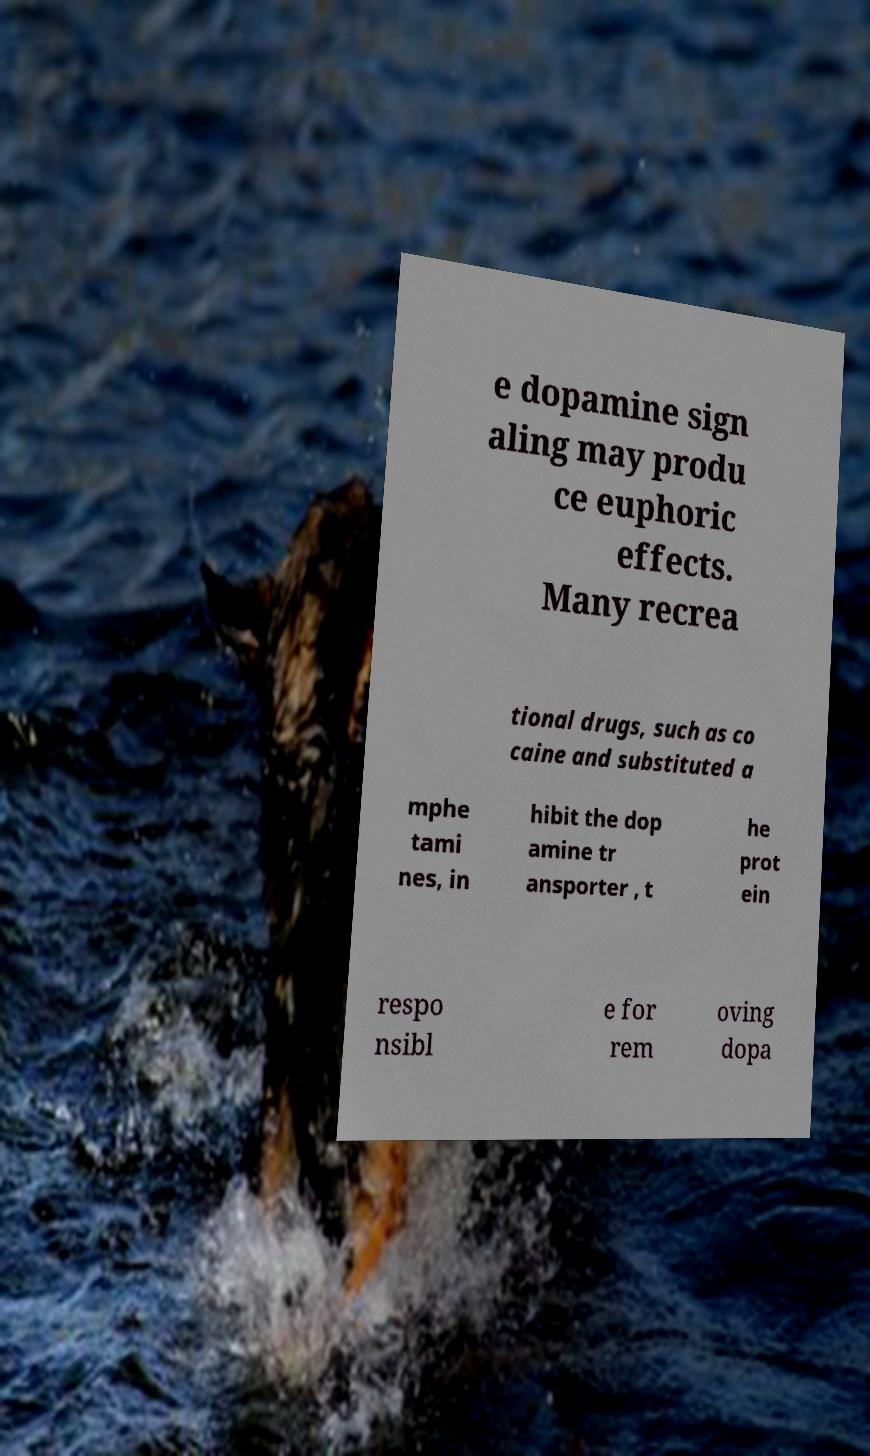Please identify and transcribe the text found in this image. e dopamine sign aling may produ ce euphoric effects. Many recrea tional drugs, such as co caine and substituted a mphe tami nes, in hibit the dop amine tr ansporter , t he prot ein respo nsibl e for rem oving dopa 